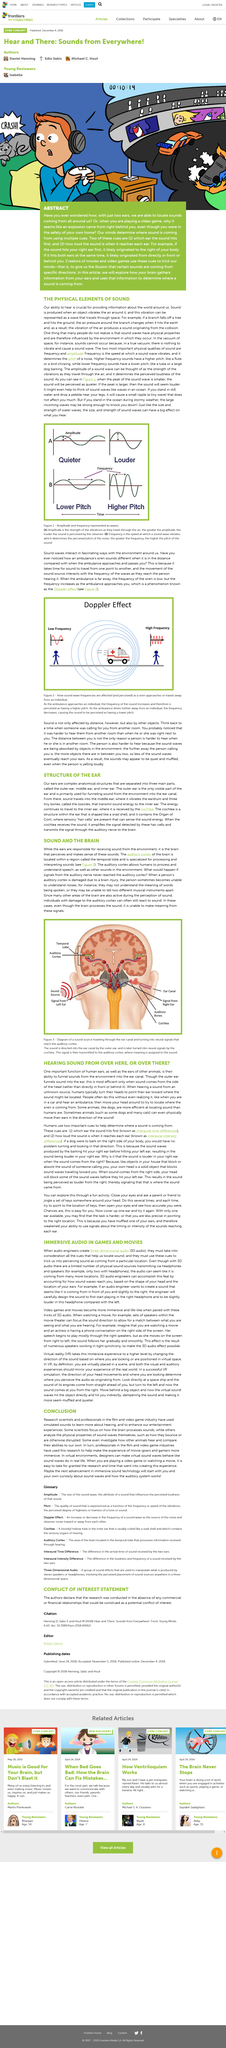Point out several critical features in this image. The cochlea is an ear structure that resembles a snail shell in its shape. It is a spiral-shaped organ that is responsible for converting sound waves into electrical signals that are sent to the brain for interpretation. The cochlea is an essential component of the auditory system and plays a vital role in our ability to hear. The human ear and the ears of other animals play a crucial role in funneling sounds from the environment into the ear canal, allowing for the detection and interpretation of auditory stimuli. The title of this document is 'Immersive Audio in Games and Movies: What Is It?'  3D audio refers to audio that has a sense of depth and space, creating a more immersive listening experience. When creating 3D audio, audio engineers must take into consideration all cues that help us locate sound and use these cues to trick our brains into perceiving the sound as coming from a particular location. 